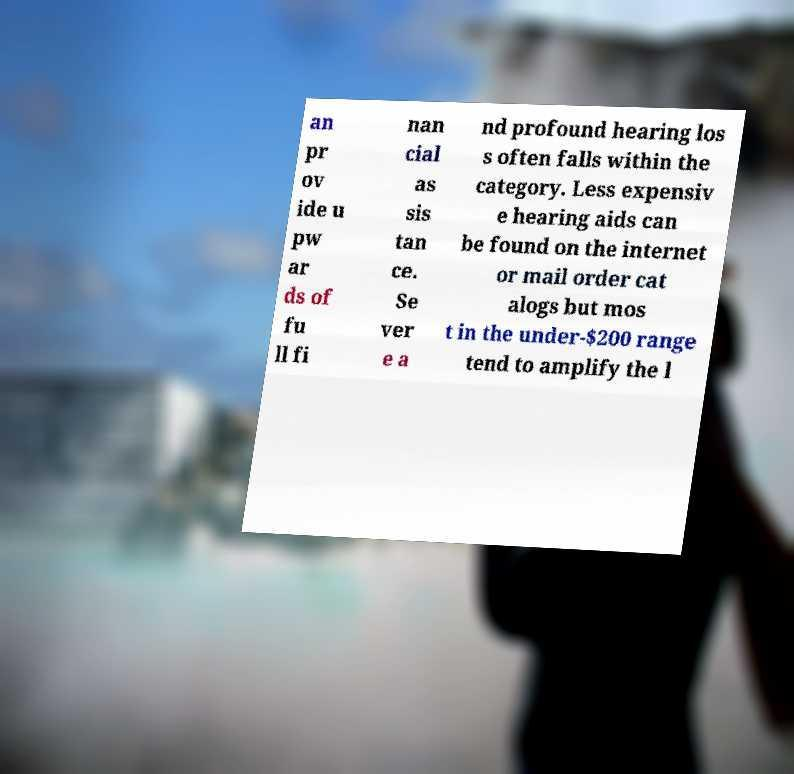Could you assist in decoding the text presented in this image and type it out clearly? an pr ov ide u pw ar ds of fu ll fi nan cial as sis tan ce. Se ver e a nd profound hearing los s often falls within the category. Less expensiv e hearing aids can be found on the internet or mail order cat alogs but mos t in the under-$200 range tend to amplify the l 